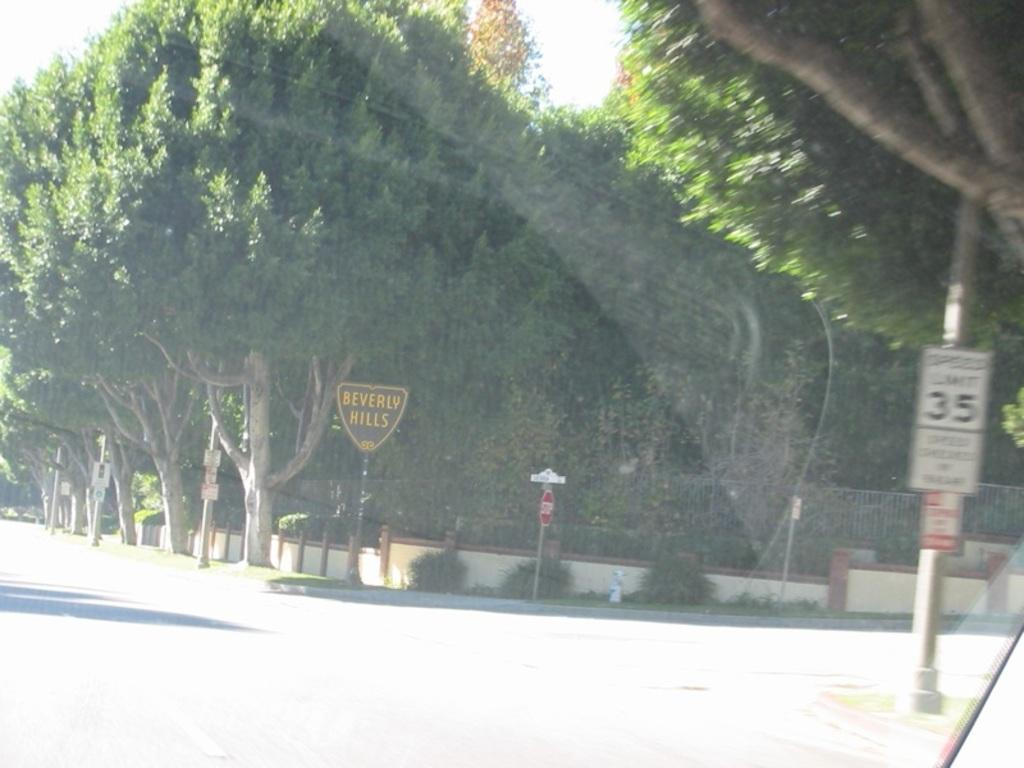What type of vegetation can be seen in the image? There are trees in the image. What is the purpose of the board in the image? The board is a stop sign. What is the iron pole used for in the image? The iron pole has a board attached to it, which is a stop sign. What type of pathway is visible in the image? There is a road in the image. What magical spell is being cast by the trees in the image? There is no magical spell being cast by the trees in the image; they are simply trees. What is the title of the book attached to the iron pole? There is no book attached to the iron pole in the image, only a stop sign. 